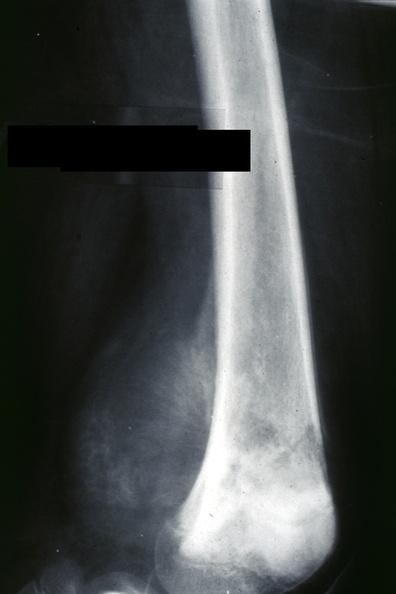what is ap view?
Answer the question using a single word or phrase. Slide 